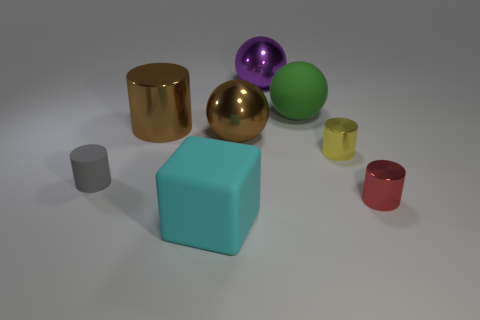Subtract all big brown spheres. How many spheres are left? 2 Add 1 small yellow things. How many objects exist? 9 Subtract all yellow cylinders. How many cylinders are left? 3 Subtract all spheres. How many objects are left? 5 Subtract 2 balls. How many balls are left? 1 Add 3 tiny red objects. How many tiny red objects are left? 4 Add 1 spheres. How many spheres exist? 4 Subtract 0 purple blocks. How many objects are left? 8 Subtract all red cylinders. Subtract all blue balls. How many cylinders are left? 3 Subtract all brown spheres. How many red cubes are left? 0 